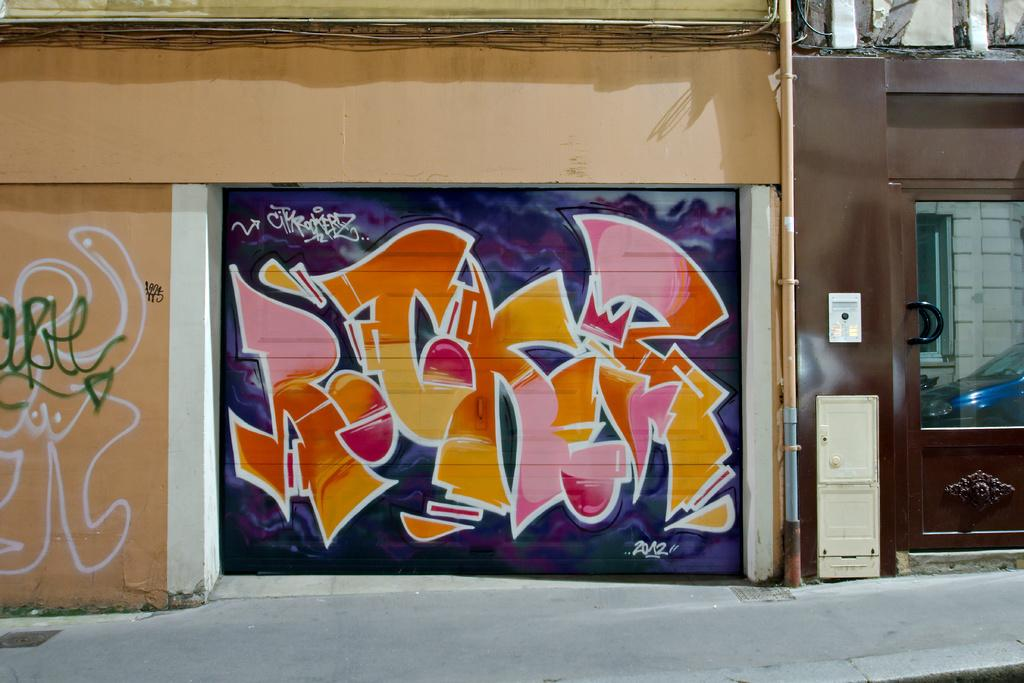What type of artwork can be seen on the walls in the image? There is graffiti painting on the walls in the image. What structure is located on the right side of the image? There is a door on the right side of the image. What is reflected on the glass window in the image? The reflection of a car is visible on a glass window in the image. Are there any bears visible in the image? No, there are no bears present in the image. Is there a hose attached to the door in the image? No, there is no hose attached to the door in the image. 